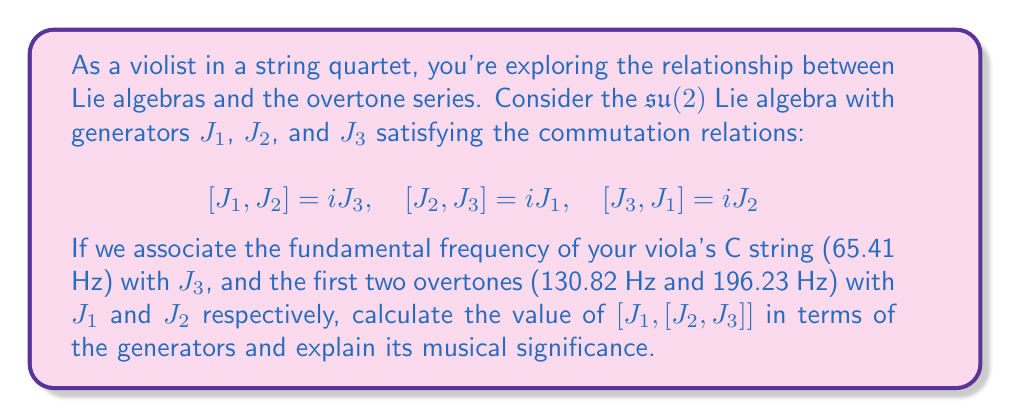Show me your answer to this math problem. To solve this problem, we'll use the Jacobi identity and the given commutation relations of the $\mathfrak{su}(2)$ Lie algebra. Let's break it down step by step:

1) First, let's calculate $[J_2, J_3]$:
   We're given that $[J_2, J_3] = iJ_1$

2) Now, we need to calculate $[J_1, [J_2, J_3]]$:
   $[J_1, [J_2, J_3]] = [J_1, iJ_1] = i[J_1, J_1] = 0$

   This is because the commutator of any element with itself is always zero.

3) However, we can gain more insight by using the Jacobi identity:
   $[J_1, [J_2, J_3]] + [J_2, [J_3, J_1]] + [J_3, [J_1, J_2]] = 0$

4) We know that:
   $[J_3, J_1] = iJ_2$
   $[J_1, J_2] = iJ_3$

5) Substituting these into the Jacobi identity:
   $[J_1, [J_2, J_3]] + [J_2, iJ_2] + [J_3, iJ_3] = 0$

6) The second and third terms are zero (as any element commuted with itself is zero), so:
   $[J_1, [J_2, J_3]] = 0$

Musical significance:
In terms of the overtone series, this result suggests a harmonic relationship between the fundamental frequency and its overtones. The fact that $[J_1, [J_2, J_3]] = 0$ implies a stable, resonant structure in the overtone series.

The fundamental frequency (65.41 Hz, associated with $J_3$) and its first two overtones (130.82 Hz and 196.23 Hz, associated with $J_1$ and $J_2$) form a perfect fifth and a perfect fourth, respectively. These intervals are known for their stability and consonance in music.

The zero commutator indicates that these frequencies interact in a way that preserves the overall structure of the overtone series, contributing to the rich, harmonious sound of the viola. This mathematical relationship mirrors the physical reality of standing waves in the instrument's string, where these specific frequency ratios naturally reinforce each other.
Answer: $[J_1, [J_2, J_3]] = 0$ 